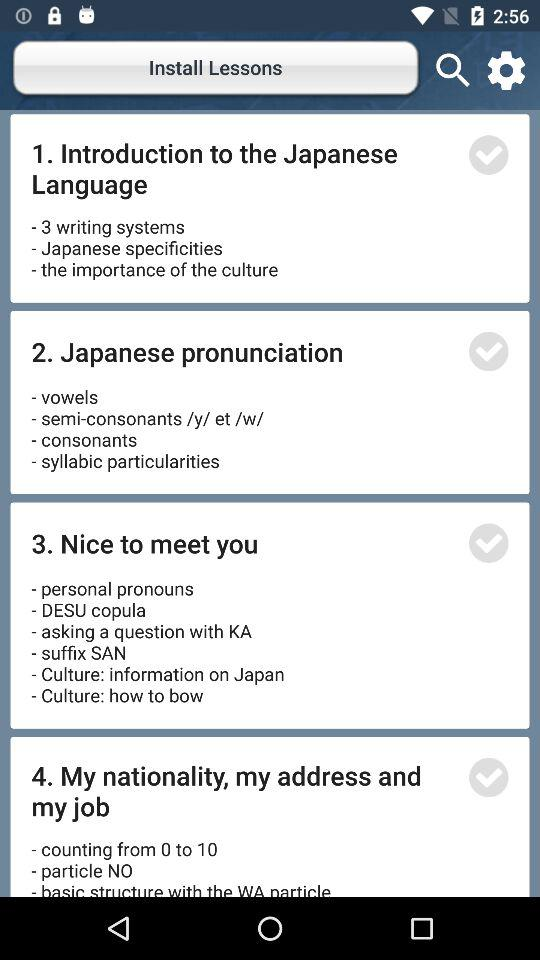How many lessons are there in total?
Answer the question using a single word or phrase. 4 